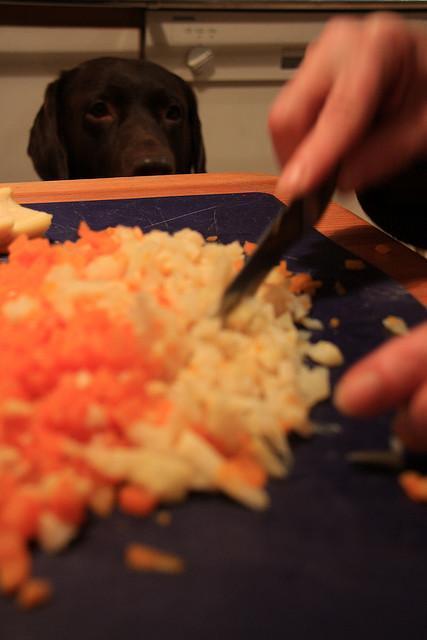How many carrots are there?
Give a very brief answer. 6. How many dogs are there?
Give a very brief answer. 1. 